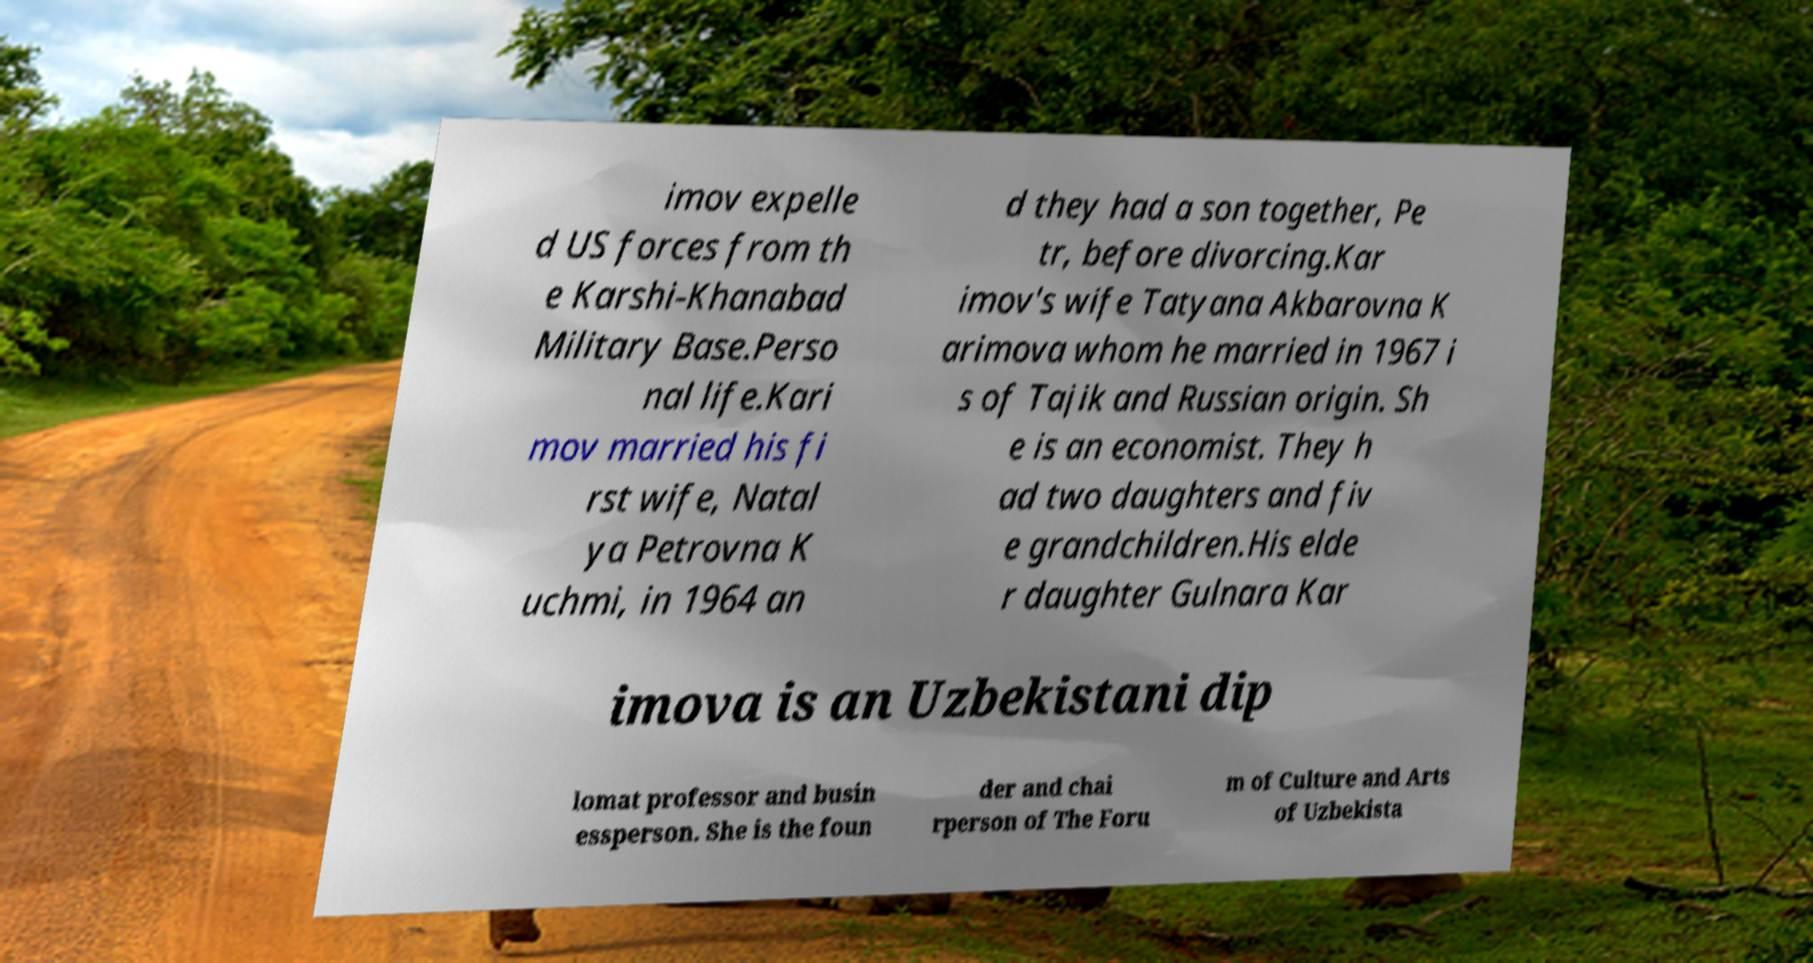For documentation purposes, I need the text within this image transcribed. Could you provide that? imov expelle d US forces from th e Karshi-Khanabad Military Base.Perso nal life.Kari mov married his fi rst wife, Natal ya Petrovna K uchmi, in 1964 an d they had a son together, Pe tr, before divorcing.Kar imov's wife Tatyana Akbarovna K arimova whom he married in 1967 i s of Tajik and Russian origin. Sh e is an economist. They h ad two daughters and fiv e grandchildren.His elde r daughter Gulnara Kar imova is an Uzbekistani dip lomat professor and busin essperson. She is the foun der and chai rperson of The Foru m of Culture and Arts of Uzbekista 